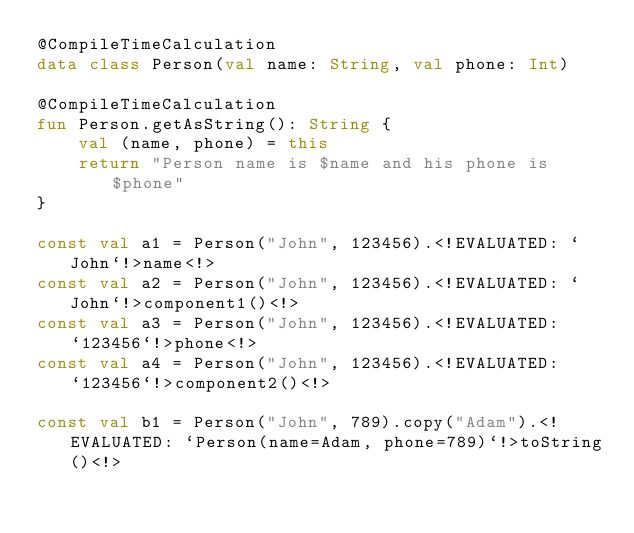Convert code to text. <code><loc_0><loc_0><loc_500><loc_500><_Kotlin_>@CompileTimeCalculation
data class Person(val name: String, val phone: Int)

@CompileTimeCalculation
fun Person.getAsString(): String {
    val (name, phone) = this
    return "Person name is $name and his phone is $phone"
}

const val a1 = Person("John", 123456).<!EVALUATED: `John`!>name<!>
const val a2 = Person("John", 123456).<!EVALUATED: `John`!>component1()<!>
const val a3 = Person("John", 123456).<!EVALUATED: `123456`!>phone<!>
const val a4 = Person("John", 123456).<!EVALUATED: `123456`!>component2()<!>

const val b1 = Person("John", 789).copy("Adam").<!EVALUATED: `Person(name=Adam, phone=789)`!>toString()<!></code> 